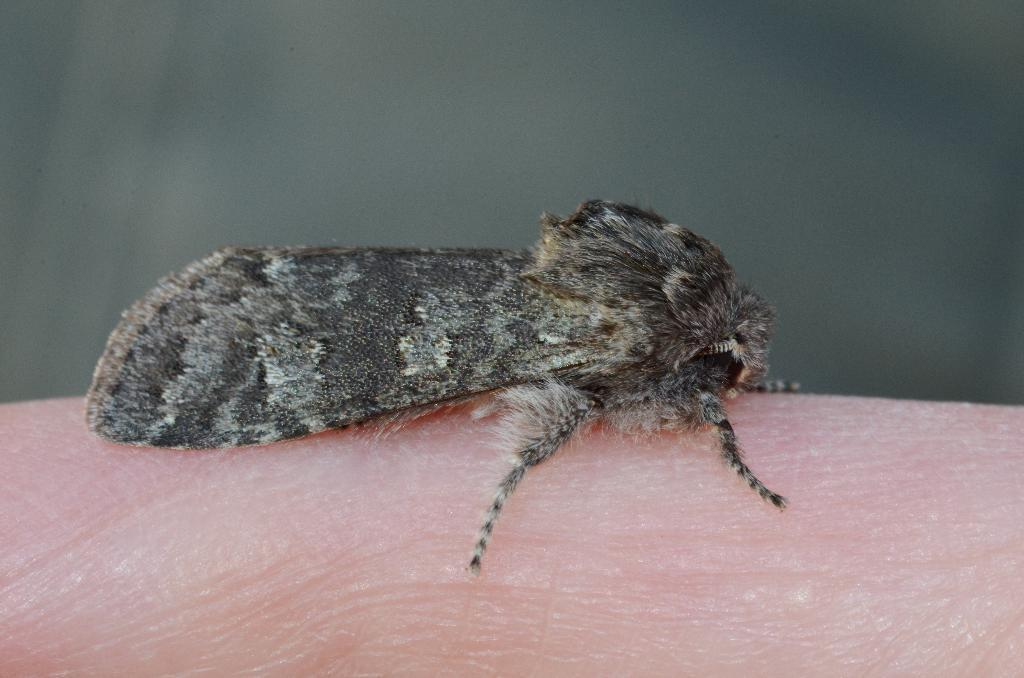What is the main subject of the image? There is a moth in the image. What is the moth resting on? The moth is on a peach surface. How would you describe the background of the image? The background of the image has a blurred view. What type of sign can be seen in the image? There is no sign present in the image; it features a moth on a peach surface with a blurred background. 